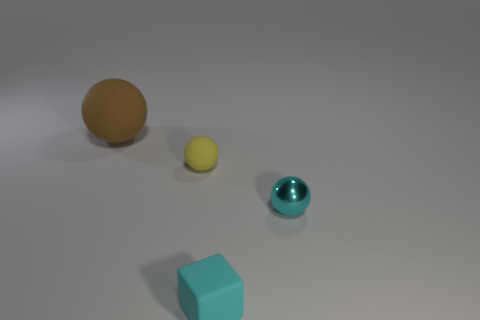What is the size of the brown sphere that is the same material as the tiny yellow thing?
Give a very brief answer. Large. What is the material of the cyan ball?
Keep it short and to the point. Metal. The thing that is the same color as the tiny block is what size?
Give a very brief answer. Small. There is a big brown object; is its shape the same as the tiny matte thing in front of the small yellow thing?
Your answer should be compact. No. What material is the ball behind the matte ball on the right side of the matte object that is behind the yellow sphere made of?
Offer a very short reply. Rubber. What number of matte things are there?
Your response must be concise. 3. What number of blue things are either small shiny cubes or small rubber balls?
Your response must be concise. 0. What number of other things are there of the same shape as the large rubber thing?
Provide a succinct answer. 2. Does the ball right of the small cyan block have the same color as the ball left of the small yellow thing?
Your answer should be very brief. No. How many large objects are either metal spheres or cyan matte objects?
Ensure brevity in your answer.  0. 